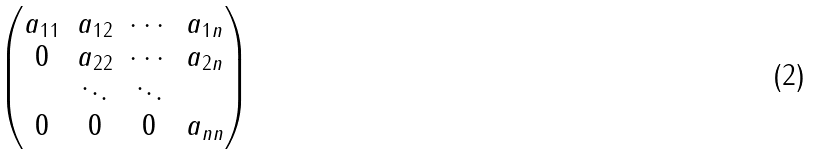Convert formula to latex. <formula><loc_0><loc_0><loc_500><loc_500>\begin{pmatrix} a _ { 1 1 } & a _ { 1 2 } & \cdots & a _ { 1 n } \\ 0 & a _ { 2 2 } & \cdots & a _ { 2 n } \\ & \ddots & \ddots & \\ 0 & 0 & 0 & a _ { n n } \end{pmatrix}</formula> 